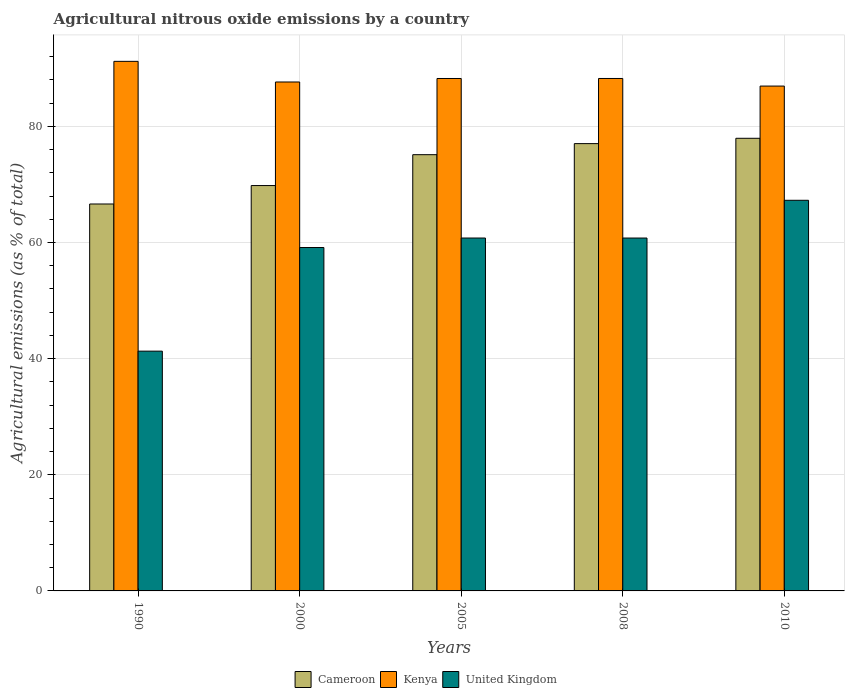Are the number of bars per tick equal to the number of legend labels?
Your answer should be very brief. Yes. How many bars are there on the 2nd tick from the left?
Your response must be concise. 3. How many bars are there on the 5th tick from the right?
Offer a very short reply. 3. In how many cases, is the number of bars for a given year not equal to the number of legend labels?
Give a very brief answer. 0. What is the amount of agricultural nitrous oxide emitted in Kenya in 1990?
Provide a succinct answer. 91.2. Across all years, what is the maximum amount of agricultural nitrous oxide emitted in Cameroon?
Offer a very short reply. 77.95. Across all years, what is the minimum amount of agricultural nitrous oxide emitted in United Kingdom?
Give a very brief answer. 41.29. What is the total amount of agricultural nitrous oxide emitted in Cameroon in the graph?
Keep it short and to the point. 366.55. What is the difference between the amount of agricultural nitrous oxide emitted in Cameroon in 1990 and that in 2000?
Give a very brief answer. -3.18. What is the difference between the amount of agricultural nitrous oxide emitted in United Kingdom in 2008 and the amount of agricultural nitrous oxide emitted in Cameroon in 2010?
Provide a short and direct response. -17.18. What is the average amount of agricultural nitrous oxide emitted in United Kingdom per year?
Keep it short and to the point. 57.85. In the year 2000, what is the difference between the amount of agricultural nitrous oxide emitted in Cameroon and amount of agricultural nitrous oxide emitted in Kenya?
Your response must be concise. -17.84. In how many years, is the amount of agricultural nitrous oxide emitted in United Kingdom greater than 4 %?
Offer a terse response. 5. What is the ratio of the amount of agricultural nitrous oxide emitted in United Kingdom in 2005 to that in 2008?
Offer a very short reply. 1. Is the amount of agricultural nitrous oxide emitted in Kenya in 2000 less than that in 2008?
Give a very brief answer. Yes. Is the difference between the amount of agricultural nitrous oxide emitted in Cameroon in 1990 and 2005 greater than the difference between the amount of agricultural nitrous oxide emitted in Kenya in 1990 and 2005?
Provide a succinct answer. No. What is the difference between the highest and the second highest amount of agricultural nitrous oxide emitted in United Kingdom?
Make the answer very short. 6.5. What is the difference between the highest and the lowest amount of agricultural nitrous oxide emitted in Kenya?
Provide a short and direct response. 4.26. Is the sum of the amount of agricultural nitrous oxide emitted in Cameroon in 1990 and 2005 greater than the maximum amount of agricultural nitrous oxide emitted in United Kingdom across all years?
Your response must be concise. Yes. How many bars are there?
Offer a very short reply. 15. Are all the bars in the graph horizontal?
Your answer should be very brief. No. How many years are there in the graph?
Ensure brevity in your answer.  5. Are the values on the major ticks of Y-axis written in scientific E-notation?
Give a very brief answer. No. Does the graph contain grids?
Ensure brevity in your answer.  Yes. How many legend labels are there?
Your answer should be compact. 3. How are the legend labels stacked?
Offer a very short reply. Horizontal. What is the title of the graph?
Keep it short and to the point. Agricultural nitrous oxide emissions by a country. Does "Italy" appear as one of the legend labels in the graph?
Your response must be concise. No. What is the label or title of the Y-axis?
Your response must be concise. Agricultural emissions (as % of total). What is the Agricultural emissions (as % of total) in Cameroon in 1990?
Your answer should be very brief. 66.63. What is the Agricultural emissions (as % of total) in Kenya in 1990?
Ensure brevity in your answer.  91.2. What is the Agricultural emissions (as % of total) of United Kingdom in 1990?
Offer a very short reply. 41.29. What is the Agricultural emissions (as % of total) of Cameroon in 2000?
Provide a short and direct response. 69.81. What is the Agricultural emissions (as % of total) in Kenya in 2000?
Provide a succinct answer. 87.65. What is the Agricultural emissions (as % of total) in United Kingdom in 2000?
Make the answer very short. 59.14. What is the Agricultural emissions (as % of total) of Cameroon in 2005?
Your response must be concise. 75.13. What is the Agricultural emissions (as % of total) of Kenya in 2005?
Make the answer very short. 88.25. What is the Agricultural emissions (as % of total) of United Kingdom in 2005?
Give a very brief answer. 60.77. What is the Agricultural emissions (as % of total) of Cameroon in 2008?
Your response must be concise. 77.03. What is the Agricultural emissions (as % of total) in Kenya in 2008?
Give a very brief answer. 88.25. What is the Agricultural emissions (as % of total) in United Kingdom in 2008?
Keep it short and to the point. 60.77. What is the Agricultural emissions (as % of total) in Cameroon in 2010?
Make the answer very short. 77.95. What is the Agricultural emissions (as % of total) in Kenya in 2010?
Give a very brief answer. 86.94. What is the Agricultural emissions (as % of total) of United Kingdom in 2010?
Give a very brief answer. 67.27. Across all years, what is the maximum Agricultural emissions (as % of total) in Cameroon?
Your answer should be very brief. 77.95. Across all years, what is the maximum Agricultural emissions (as % of total) in Kenya?
Offer a terse response. 91.2. Across all years, what is the maximum Agricultural emissions (as % of total) in United Kingdom?
Keep it short and to the point. 67.27. Across all years, what is the minimum Agricultural emissions (as % of total) of Cameroon?
Provide a succinct answer. 66.63. Across all years, what is the minimum Agricultural emissions (as % of total) of Kenya?
Give a very brief answer. 86.94. Across all years, what is the minimum Agricultural emissions (as % of total) in United Kingdom?
Ensure brevity in your answer.  41.29. What is the total Agricultural emissions (as % of total) of Cameroon in the graph?
Provide a short and direct response. 366.55. What is the total Agricultural emissions (as % of total) in Kenya in the graph?
Ensure brevity in your answer.  442.29. What is the total Agricultural emissions (as % of total) of United Kingdom in the graph?
Provide a short and direct response. 289.25. What is the difference between the Agricultural emissions (as % of total) of Cameroon in 1990 and that in 2000?
Your response must be concise. -3.18. What is the difference between the Agricultural emissions (as % of total) in Kenya in 1990 and that in 2000?
Ensure brevity in your answer.  3.55. What is the difference between the Agricultural emissions (as % of total) in United Kingdom in 1990 and that in 2000?
Provide a short and direct response. -17.85. What is the difference between the Agricultural emissions (as % of total) of Cameroon in 1990 and that in 2005?
Offer a very short reply. -8.49. What is the difference between the Agricultural emissions (as % of total) of Kenya in 1990 and that in 2005?
Ensure brevity in your answer.  2.95. What is the difference between the Agricultural emissions (as % of total) in United Kingdom in 1990 and that in 2005?
Ensure brevity in your answer.  -19.48. What is the difference between the Agricultural emissions (as % of total) in Cameroon in 1990 and that in 2008?
Your answer should be compact. -10.4. What is the difference between the Agricultural emissions (as % of total) of Kenya in 1990 and that in 2008?
Offer a terse response. 2.95. What is the difference between the Agricultural emissions (as % of total) of United Kingdom in 1990 and that in 2008?
Your response must be concise. -19.48. What is the difference between the Agricultural emissions (as % of total) in Cameroon in 1990 and that in 2010?
Offer a terse response. -11.31. What is the difference between the Agricultural emissions (as % of total) of Kenya in 1990 and that in 2010?
Your answer should be very brief. 4.26. What is the difference between the Agricultural emissions (as % of total) of United Kingdom in 1990 and that in 2010?
Provide a succinct answer. -25.98. What is the difference between the Agricultural emissions (as % of total) of Cameroon in 2000 and that in 2005?
Ensure brevity in your answer.  -5.32. What is the difference between the Agricultural emissions (as % of total) of Kenya in 2000 and that in 2005?
Your response must be concise. -0.6. What is the difference between the Agricultural emissions (as % of total) of United Kingdom in 2000 and that in 2005?
Offer a terse response. -1.63. What is the difference between the Agricultural emissions (as % of total) in Cameroon in 2000 and that in 2008?
Provide a short and direct response. -7.22. What is the difference between the Agricultural emissions (as % of total) in Kenya in 2000 and that in 2008?
Your answer should be very brief. -0.61. What is the difference between the Agricultural emissions (as % of total) of United Kingdom in 2000 and that in 2008?
Ensure brevity in your answer.  -1.63. What is the difference between the Agricultural emissions (as % of total) of Cameroon in 2000 and that in 2010?
Your answer should be compact. -8.14. What is the difference between the Agricultural emissions (as % of total) in Kenya in 2000 and that in 2010?
Provide a short and direct response. 0.7. What is the difference between the Agricultural emissions (as % of total) in United Kingdom in 2000 and that in 2010?
Your response must be concise. -8.13. What is the difference between the Agricultural emissions (as % of total) in Cameroon in 2005 and that in 2008?
Keep it short and to the point. -1.9. What is the difference between the Agricultural emissions (as % of total) of Kenya in 2005 and that in 2008?
Provide a short and direct response. -0. What is the difference between the Agricultural emissions (as % of total) of United Kingdom in 2005 and that in 2008?
Ensure brevity in your answer.  0. What is the difference between the Agricultural emissions (as % of total) of Cameroon in 2005 and that in 2010?
Make the answer very short. -2.82. What is the difference between the Agricultural emissions (as % of total) of Kenya in 2005 and that in 2010?
Keep it short and to the point. 1.3. What is the difference between the Agricultural emissions (as % of total) of United Kingdom in 2005 and that in 2010?
Ensure brevity in your answer.  -6.5. What is the difference between the Agricultural emissions (as % of total) in Cameroon in 2008 and that in 2010?
Offer a terse response. -0.92. What is the difference between the Agricultural emissions (as % of total) of Kenya in 2008 and that in 2010?
Make the answer very short. 1.31. What is the difference between the Agricultural emissions (as % of total) of United Kingdom in 2008 and that in 2010?
Your answer should be compact. -6.5. What is the difference between the Agricultural emissions (as % of total) of Cameroon in 1990 and the Agricultural emissions (as % of total) of Kenya in 2000?
Your answer should be compact. -21.01. What is the difference between the Agricultural emissions (as % of total) of Cameroon in 1990 and the Agricultural emissions (as % of total) of United Kingdom in 2000?
Offer a terse response. 7.5. What is the difference between the Agricultural emissions (as % of total) in Kenya in 1990 and the Agricultural emissions (as % of total) in United Kingdom in 2000?
Your response must be concise. 32.06. What is the difference between the Agricultural emissions (as % of total) of Cameroon in 1990 and the Agricultural emissions (as % of total) of Kenya in 2005?
Your response must be concise. -21.61. What is the difference between the Agricultural emissions (as % of total) of Cameroon in 1990 and the Agricultural emissions (as % of total) of United Kingdom in 2005?
Keep it short and to the point. 5.86. What is the difference between the Agricultural emissions (as % of total) of Kenya in 1990 and the Agricultural emissions (as % of total) of United Kingdom in 2005?
Provide a succinct answer. 30.43. What is the difference between the Agricultural emissions (as % of total) in Cameroon in 1990 and the Agricultural emissions (as % of total) in Kenya in 2008?
Ensure brevity in your answer.  -21.62. What is the difference between the Agricultural emissions (as % of total) in Cameroon in 1990 and the Agricultural emissions (as % of total) in United Kingdom in 2008?
Keep it short and to the point. 5.86. What is the difference between the Agricultural emissions (as % of total) in Kenya in 1990 and the Agricultural emissions (as % of total) in United Kingdom in 2008?
Offer a very short reply. 30.43. What is the difference between the Agricultural emissions (as % of total) in Cameroon in 1990 and the Agricultural emissions (as % of total) in Kenya in 2010?
Give a very brief answer. -20.31. What is the difference between the Agricultural emissions (as % of total) of Cameroon in 1990 and the Agricultural emissions (as % of total) of United Kingdom in 2010?
Keep it short and to the point. -0.64. What is the difference between the Agricultural emissions (as % of total) of Kenya in 1990 and the Agricultural emissions (as % of total) of United Kingdom in 2010?
Offer a terse response. 23.93. What is the difference between the Agricultural emissions (as % of total) in Cameroon in 2000 and the Agricultural emissions (as % of total) in Kenya in 2005?
Give a very brief answer. -18.44. What is the difference between the Agricultural emissions (as % of total) of Cameroon in 2000 and the Agricultural emissions (as % of total) of United Kingdom in 2005?
Offer a terse response. 9.04. What is the difference between the Agricultural emissions (as % of total) in Kenya in 2000 and the Agricultural emissions (as % of total) in United Kingdom in 2005?
Provide a short and direct response. 26.87. What is the difference between the Agricultural emissions (as % of total) of Cameroon in 2000 and the Agricultural emissions (as % of total) of Kenya in 2008?
Offer a terse response. -18.44. What is the difference between the Agricultural emissions (as % of total) of Cameroon in 2000 and the Agricultural emissions (as % of total) of United Kingdom in 2008?
Your answer should be very brief. 9.04. What is the difference between the Agricultural emissions (as % of total) in Kenya in 2000 and the Agricultural emissions (as % of total) in United Kingdom in 2008?
Give a very brief answer. 26.87. What is the difference between the Agricultural emissions (as % of total) in Cameroon in 2000 and the Agricultural emissions (as % of total) in Kenya in 2010?
Make the answer very short. -17.13. What is the difference between the Agricultural emissions (as % of total) of Cameroon in 2000 and the Agricultural emissions (as % of total) of United Kingdom in 2010?
Your answer should be very brief. 2.54. What is the difference between the Agricultural emissions (as % of total) in Kenya in 2000 and the Agricultural emissions (as % of total) in United Kingdom in 2010?
Your answer should be compact. 20.37. What is the difference between the Agricultural emissions (as % of total) in Cameroon in 2005 and the Agricultural emissions (as % of total) in Kenya in 2008?
Ensure brevity in your answer.  -13.12. What is the difference between the Agricultural emissions (as % of total) of Cameroon in 2005 and the Agricultural emissions (as % of total) of United Kingdom in 2008?
Make the answer very short. 14.36. What is the difference between the Agricultural emissions (as % of total) in Kenya in 2005 and the Agricultural emissions (as % of total) in United Kingdom in 2008?
Your answer should be compact. 27.47. What is the difference between the Agricultural emissions (as % of total) in Cameroon in 2005 and the Agricultural emissions (as % of total) in Kenya in 2010?
Give a very brief answer. -11.82. What is the difference between the Agricultural emissions (as % of total) of Cameroon in 2005 and the Agricultural emissions (as % of total) of United Kingdom in 2010?
Your answer should be compact. 7.85. What is the difference between the Agricultural emissions (as % of total) of Kenya in 2005 and the Agricultural emissions (as % of total) of United Kingdom in 2010?
Keep it short and to the point. 20.97. What is the difference between the Agricultural emissions (as % of total) of Cameroon in 2008 and the Agricultural emissions (as % of total) of Kenya in 2010?
Give a very brief answer. -9.91. What is the difference between the Agricultural emissions (as % of total) in Cameroon in 2008 and the Agricultural emissions (as % of total) in United Kingdom in 2010?
Make the answer very short. 9.76. What is the difference between the Agricultural emissions (as % of total) of Kenya in 2008 and the Agricultural emissions (as % of total) of United Kingdom in 2010?
Provide a short and direct response. 20.98. What is the average Agricultural emissions (as % of total) in Cameroon per year?
Offer a terse response. 73.31. What is the average Agricultural emissions (as % of total) in Kenya per year?
Provide a succinct answer. 88.46. What is the average Agricultural emissions (as % of total) in United Kingdom per year?
Provide a succinct answer. 57.85. In the year 1990, what is the difference between the Agricultural emissions (as % of total) in Cameroon and Agricultural emissions (as % of total) in Kenya?
Make the answer very short. -24.57. In the year 1990, what is the difference between the Agricultural emissions (as % of total) of Cameroon and Agricultural emissions (as % of total) of United Kingdom?
Your response must be concise. 25.34. In the year 1990, what is the difference between the Agricultural emissions (as % of total) of Kenya and Agricultural emissions (as % of total) of United Kingdom?
Make the answer very short. 49.91. In the year 2000, what is the difference between the Agricultural emissions (as % of total) of Cameroon and Agricultural emissions (as % of total) of Kenya?
Make the answer very short. -17.84. In the year 2000, what is the difference between the Agricultural emissions (as % of total) in Cameroon and Agricultural emissions (as % of total) in United Kingdom?
Your answer should be compact. 10.67. In the year 2000, what is the difference between the Agricultural emissions (as % of total) of Kenya and Agricultural emissions (as % of total) of United Kingdom?
Your answer should be very brief. 28.51. In the year 2005, what is the difference between the Agricultural emissions (as % of total) of Cameroon and Agricultural emissions (as % of total) of Kenya?
Give a very brief answer. -13.12. In the year 2005, what is the difference between the Agricultural emissions (as % of total) in Cameroon and Agricultural emissions (as % of total) in United Kingdom?
Your answer should be very brief. 14.35. In the year 2005, what is the difference between the Agricultural emissions (as % of total) of Kenya and Agricultural emissions (as % of total) of United Kingdom?
Give a very brief answer. 27.47. In the year 2008, what is the difference between the Agricultural emissions (as % of total) in Cameroon and Agricultural emissions (as % of total) in Kenya?
Keep it short and to the point. -11.22. In the year 2008, what is the difference between the Agricultural emissions (as % of total) of Cameroon and Agricultural emissions (as % of total) of United Kingdom?
Offer a very short reply. 16.26. In the year 2008, what is the difference between the Agricultural emissions (as % of total) of Kenya and Agricultural emissions (as % of total) of United Kingdom?
Offer a very short reply. 27.48. In the year 2010, what is the difference between the Agricultural emissions (as % of total) of Cameroon and Agricultural emissions (as % of total) of Kenya?
Keep it short and to the point. -8.99. In the year 2010, what is the difference between the Agricultural emissions (as % of total) of Cameroon and Agricultural emissions (as % of total) of United Kingdom?
Keep it short and to the point. 10.68. In the year 2010, what is the difference between the Agricultural emissions (as % of total) in Kenya and Agricultural emissions (as % of total) in United Kingdom?
Provide a short and direct response. 19.67. What is the ratio of the Agricultural emissions (as % of total) in Cameroon in 1990 to that in 2000?
Keep it short and to the point. 0.95. What is the ratio of the Agricultural emissions (as % of total) of Kenya in 1990 to that in 2000?
Your answer should be very brief. 1.04. What is the ratio of the Agricultural emissions (as % of total) of United Kingdom in 1990 to that in 2000?
Ensure brevity in your answer.  0.7. What is the ratio of the Agricultural emissions (as % of total) in Cameroon in 1990 to that in 2005?
Make the answer very short. 0.89. What is the ratio of the Agricultural emissions (as % of total) of Kenya in 1990 to that in 2005?
Offer a terse response. 1.03. What is the ratio of the Agricultural emissions (as % of total) of United Kingdom in 1990 to that in 2005?
Your response must be concise. 0.68. What is the ratio of the Agricultural emissions (as % of total) in Cameroon in 1990 to that in 2008?
Ensure brevity in your answer.  0.86. What is the ratio of the Agricultural emissions (as % of total) in Kenya in 1990 to that in 2008?
Provide a succinct answer. 1.03. What is the ratio of the Agricultural emissions (as % of total) in United Kingdom in 1990 to that in 2008?
Provide a short and direct response. 0.68. What is the ratio of the Agricultural emissions (as % of total) in Cameroon in 1990 to that in 2010?
Your answer should be compact. 0.85. What is the ratio of the Agricultural emissions (as % of total) in Kenya in 1990 to that in 2010?
Offer a terse response. 1.05. What is the ratio of the Agricultural emissions (as % of total) in United Kingdom in 1990 to that in 2010?
Provide a succinct answer. 0.61. What is the ratio of the Agricultural emissions (as % of total) of Cameroon in 2000 to that in 2005?
Offer a very short reply. 0.93. What is the ratio of the Agricultural emissions (as % of total) of United Kingdom in 2000 to that in 2005?
Keep it short and to the point. 0.97. What is the ratio of the Agricultural emissions (as % of total) of Cameroon in 2000 to that in 2008?
Your response must be concise. 0.91. What is the ratio of the Agricultural emissions (as % of total) of United Kingdom in 2000 to that in 2008?
Offer a terse response. 0.97. What is the ratio of the Agricultural emissions (as % of total) of Cameroon in 2000 to that in 2010?
Ensure brevity in your answer.  0.9. What is the ratio of the Agricultural emissions (as % of total) in Kenya in 2000 to that in 2010?
Ensure brevity in your answer.  1.01. What is the ratio of the Agricultural emissions (as % of total) in United Kingdom in 2000 to that in 2010?
Provide a succinct answer. 0.88. What is the ratio of the Agricultural emissions (as % of total) in Cameroon in 2005 to that in 2008?
Offer a very short reply. 0.98. What is the ratio of the Agricultural emissions (as % of total) of Kenya in 2005 to that in 2008?
Your answer should be compact. 1. What is the ratio of the Agricultural emissions (as % of total) in United Kingdom in 2005 to that in 2008?
Your answer should be very brief. 1. What is the ratio of the Agricultural emissions (as % of total) of Cameroon in 2005 to that in 2010?
Offer a terse response. 0.96. What is the ratio of the Agricultural emissions (as % of total) of United Kingdom in 2005 to that in 2010?
Your answer should be compact. 0.9. What is the ratio of the Agricultural emissions (as % of total) of Cameroon in 2008 to that in 2010?
Give a very brief answer. 0.99. What is the ratio of the Agricultural emissions (as % of total) in Kenya in 2008 to that in 2010?
Offer a terse response. 1.01. What is the ratio of the Agricultural emissions (as % of total) in United Kingdom in 2008 to that in 2010?
Give a very brief answer. 0.9. What is the difference between the highest and the second highest Agricultural emissions (as % of total) of Cameroon?
Provide a succinct answer. 0.92. What is the difference between the highest and the second highest Agricultural emissions (as % of total) in Kenya?
Keep it short and to the point. 2.95. What is the difference between the highest and the second highest Agricultural emissions (as % of total) in United Kingdom?
Keep it short and to the point. 6.5. What is the difference between the highest and the lowest Agricultural emissions (as % of total) of Cameroon?
Offer a terse response. 11.31. What is the difference between the highest and the lowest Agricultural emissions (as % of total) in Kenya?
Your response must be concise. 4.26. What is the difference between the highest and the lowest Agricultural emissions (as % of total) of United Kingdom?
Your answer should be very brief. 25.98. 